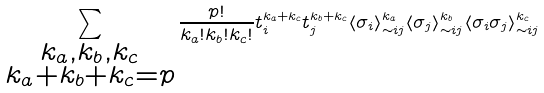Convert formula to latex. <formula><loc_0><loc_0><loc_500><loc_500>\sum _ { \substack { k _ { a } , k _ { b } , k _ { c } \\ k _ { a } + k _ { b } + k _ { c } = p } } \frac { p ! } { k _ { a } ! k _ { b } ! k _ { c } ! } t _ { i } ^ { k _ { a } + k _ { c } } t _ { j } ^ { k _ { b } + k _ { c } } \langle \sigma _ { i } \rangle _ { \sim i j } ^ { k _ { a } } \langle \sigma _ { j } \rangle _ { \sim i j } ^ { k _ { b } } \langle \sigma _ { i } \sigma _ { j } \rangle _ { \sim i j } ^ { k _ { c } }</formula> 